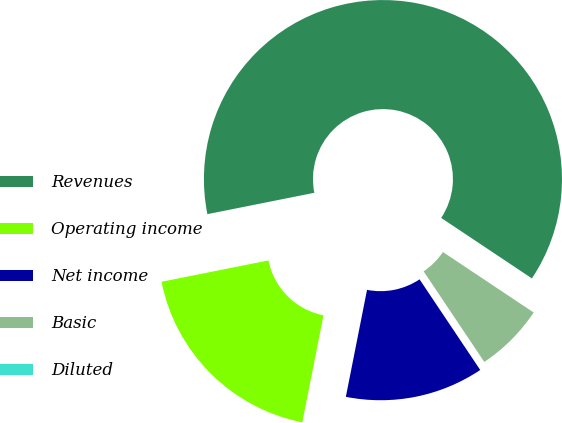Convert chart. <chart><loc_0><loc_0><loc_500><loc_500><pie_chart><fcel>Revenues<fcel>Operating income<fcel>Net income<fcel>Basic<fcel>Diluted<nl><fcel>62.5%<fcel>18.75%<fcel>12.5%<fcel>6.25%<fcel>0.0%<nl></chart> 